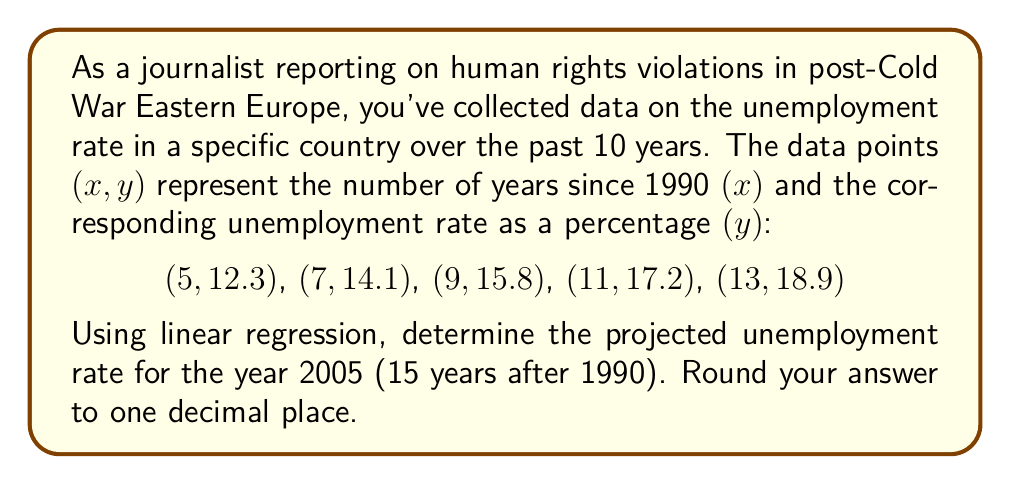What is the answer to this math problem? To solve this problem using linear regression, we'll follow these steps:

1. Calculate the means of x and y:
   $\bar{x} = \frac{5 + 7 + 9 + 11 + 13}{5} = 9$
   $\bar{y} = \frac{12.3 + 14.1 + 15.8 + 17.2 + 18.9}{5} = 15.66$

2. Calculate the slope (m) using the formula:
   $$m = \frac{\sum(x_i - \bar{x})(y_i - \bar{y})}{\sum(x_i - \bar{x})^2}$$

   $\sum(x_i - \bar{x})(y_i - \bar{y}) = (-4)(-3.36) + (-2)(-1.56) + (0)(0.14) + (2)(1.54) + (4)(3.24) = 28.64$
   $\sum(x_i - \bar{x})^2 = (-4)^2 + (-2)^2 + 0^2 + 2^2 + 4^2 = 40$

   $m = \frac{28.64}{40} = 0.716$

3. Calculate the y-intercept (b) using the point-slope form:
   $b = \bar{y} - m\bar{x} = 15.66 - 0.716(9) = 9.216$

4. The linear regression equation is:
   $y = 0.716x + 9.216$

5. To project the unemployment rate for 2005 (15 years after 1990), substitute x = 15:
   $y = 0.716(15) + 9.216 = 19.956$

6. Rounding to one decimal place: 20.0%
Answer: 20.0% 